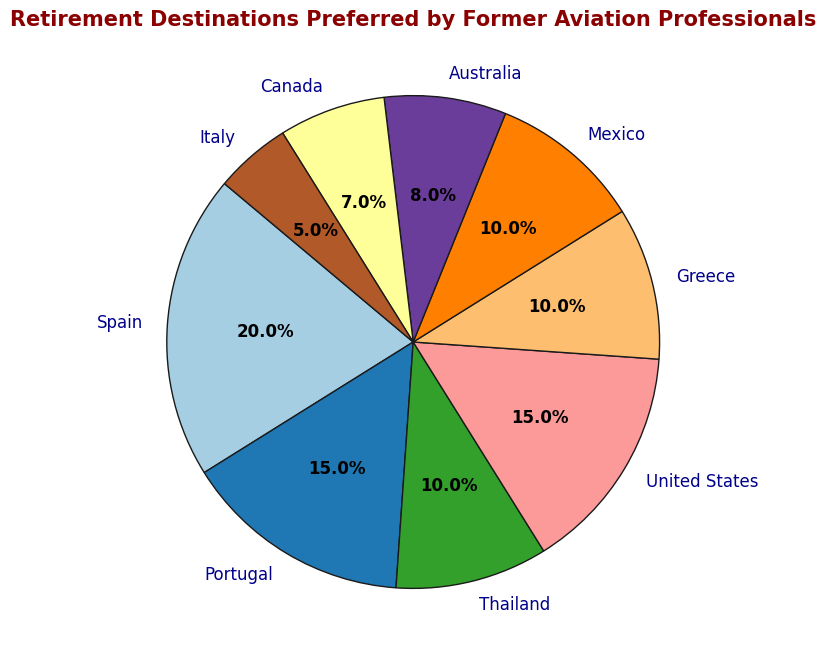Which destination has the highest percentage of retired aviation professionals? Identify the segment with the largest value. Spain has the highest percentage, as indicated by the largest slice, which is 20%.
Answer: Spain Which two destinations have the same percentage of retired aviation professionals? Check for identical values in the percentages. Both the United States and Portugal have 15%.
Answer: United States and Portugal What is the combined percentage of aviation professionals retired in Thailand and Mexico? Add the individual percentages of Thailand and Mexico. Thailand contributes 10% and Mexico adds another 10%, so the sum is 10% + 10% = 20%.
Answer: 20% How many destinations have a percentage less than 10%? Count the segments where the percentage is less than 10. Australia (8%), Canada (7%), and Italy (5%) each have percentages below 10%, making a total of three destinations.
Answer: 3 What is the difference in the percentage points between Spain and Greece? Subtract the percentage for Greece from the percentage for Spain. Spain has 20%, and Greece has 10%, so 20% - 10% = 10%.
Answer: 10% Which destination has the smallest percentage of retired aviation professionals? Identify the smallest segment in the pie chart. Italy has the smallest percentage, which is 5%.
Answer: Italy Which destination segment is visually represented with a color closest to red in the chart? Determine the color used for each segment. Australia, represented with the color closest to red in 'tableau-colorblind10' palette, is the segment you are looking for.
Answer: Australia What is the total percentage of aviation professionals retired in North American destinations (United States, Mexico, and Canada)? Sum the percentages of the given North American destinations. United States has 15%, Mexico has 10%, and Canada has 7%. The total is 15% + 10% + 7% = 32%.
Answer: 32% Compare the percentages of retired aviation professionals in Europe (Spain, Portugal, Greece, and Italy). Which one has the highest percentage? Analyze the European destinations in the chart and identify the highest percentage. Among Spain (20%), Portugal (15%), Greece (10%), and Italy (5%), Spain leads with 20%.
Answer: Spain 